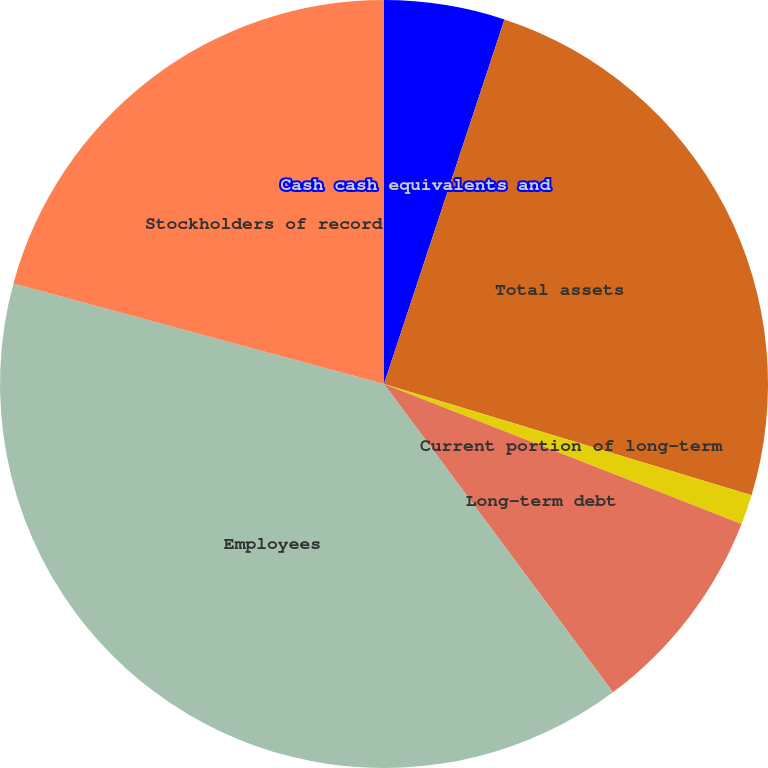Convert chart to OTSL. <chart><loc_0><loc_0><loc_500><loc_500><pie_chart><fcel>Cash cash equivalents and<fcel>Total assets<fcel>Current portion of long-term<fcel>Long-term debt<fcel>Employees<fcel>Stockholders of record<nl><fcel>5.08%<fcel>24.59%<fcel>1.27%<fcel>8.89%<fcel>39.38%<fcel>20.78%<nl></chart> 